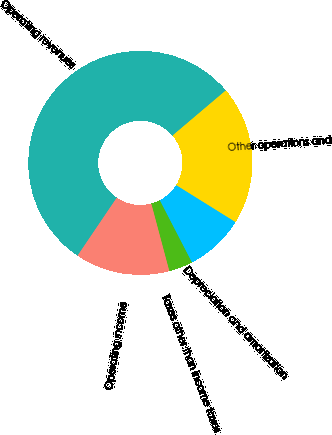Convert chart to OTSL. <chart><loc_0><loc_0><loc_500><loc_500><pie_chart><fcel>Operating revenues<fcel>Other operations and<fcel>Depreciation and amortization<fcel>Taxes other than income taxes<fcel>Operating income<nl><fcel>54.35%<fcel>20.06%<fcel>8.53%<fcel>3.44%<fcel>13.62%<nl></chart> 